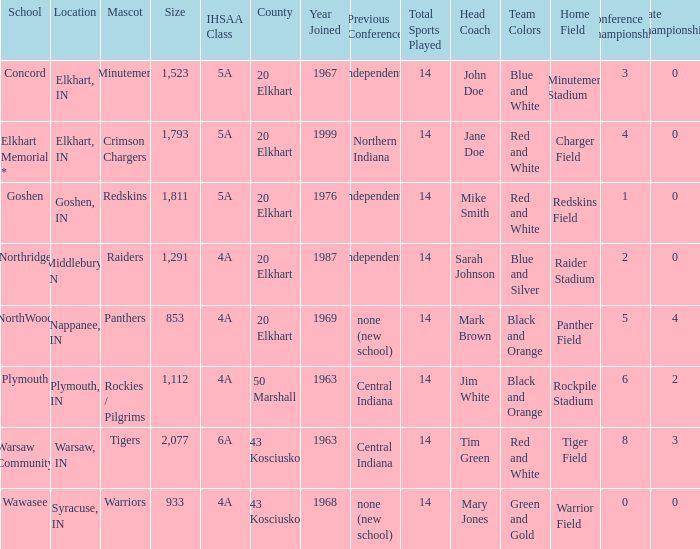What is the IHSAA class for the team located in Middlebury, IN? 4A. 